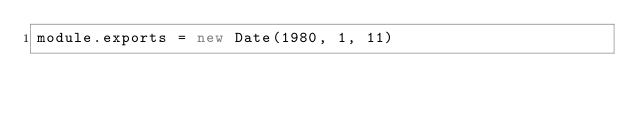Convert code to text. <code><loc_0><loc_0><loc_500><loc_500><_JavaScript_>module.exports = new Date(1980, 1, 11)
</code> 